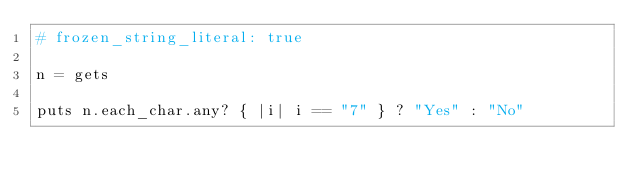Convert code to text. <code><loc_0><loc_0><loc_500><loc_500><_Ruby_># frozen_string_literal: true

n = gets

puts n.each_char.any? { |i| i == "7" } ? "Yes" : "No"
</code> 